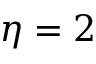<formula> <loc_0><loc_0><loc_500><loc_500>\eta = 2</formula> 